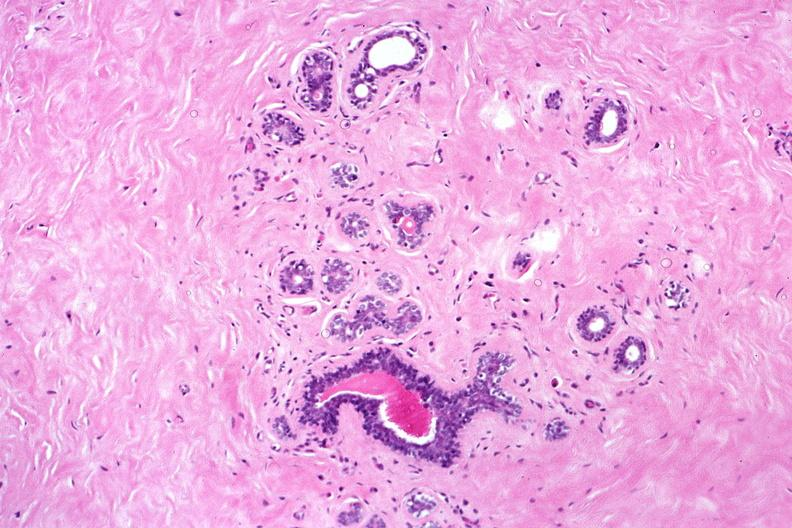what does this image show?
Answer the question using a single word or phrase. Normal breast 